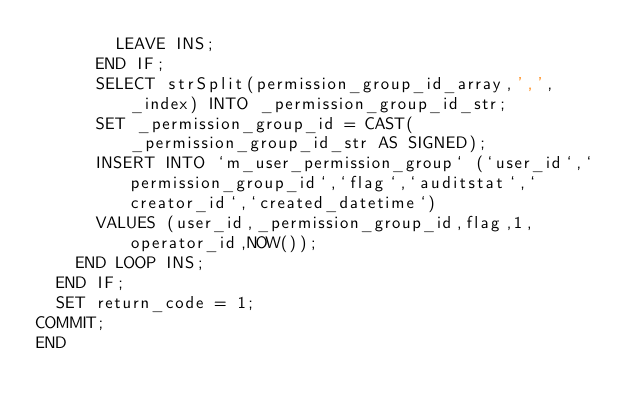Convert code to text. <code><loc_0><loc_0><loc_500><loc_500><_SQL_>        LEAVE INS;
      END IF;
      SELECT strSplit(permission_group_id_array,',', _index) INTO _permission_group_id_str;
      SET _permission_group_id = CAST(_permission_group_id_str AS SIGNED);
      INSERT INTO `m_user_permission_group` (`user_id`,`permission_group_id`,`flag`,`auditstat`,`creator_id`,`created_datetime`)
      VALUES (user_id,_permission_group_id,flag,1,operator_id,NOW());
    END LOOP INS;
  END IF;
  SET return_code = 1;
COMMIT;
END
</code> 